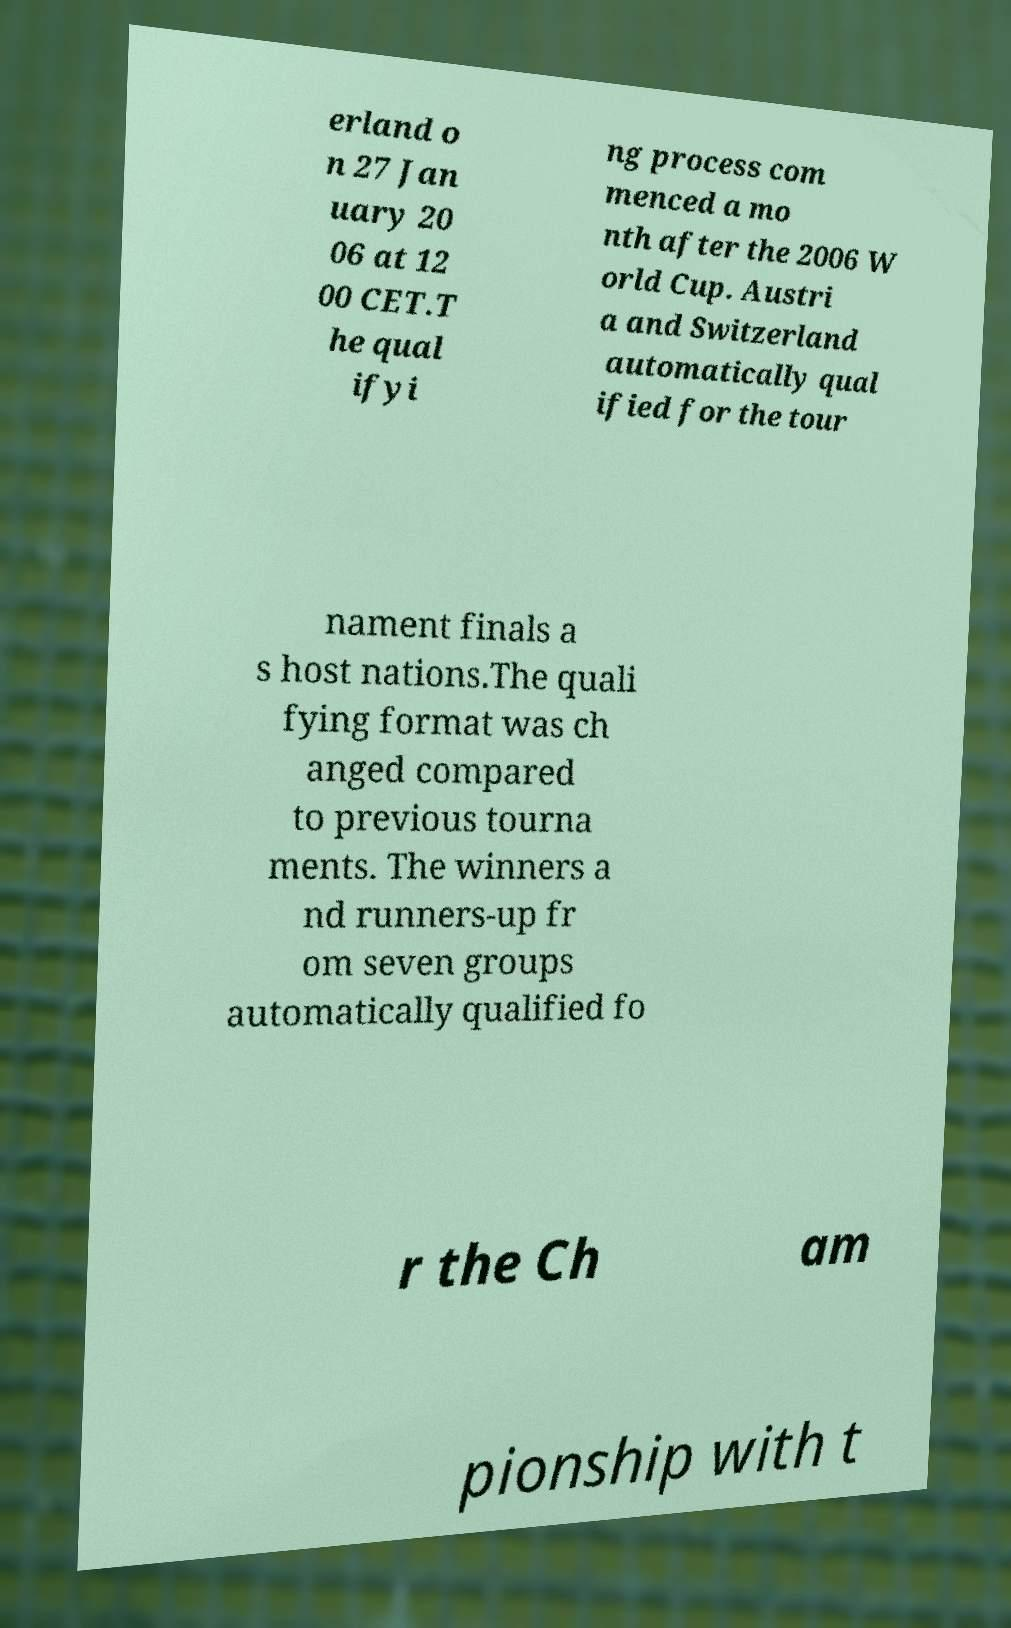There's text embedded in this image that I need extracted. Can you transcribe it verbatim? erland o n 27 Jan uary 20 06 at 12 00 CET.T he qual ifyi ng process com menced a mo nth after the 2006 W orld Cup. Austri a and Switzerland automatically qual ified for the tour nament finals a s host nations.The quali fying format was ch anged compared to previous tourna ments. The winners a nd runners-up fr om seven groups automatically qualified fo r the Ch am pionship with t 